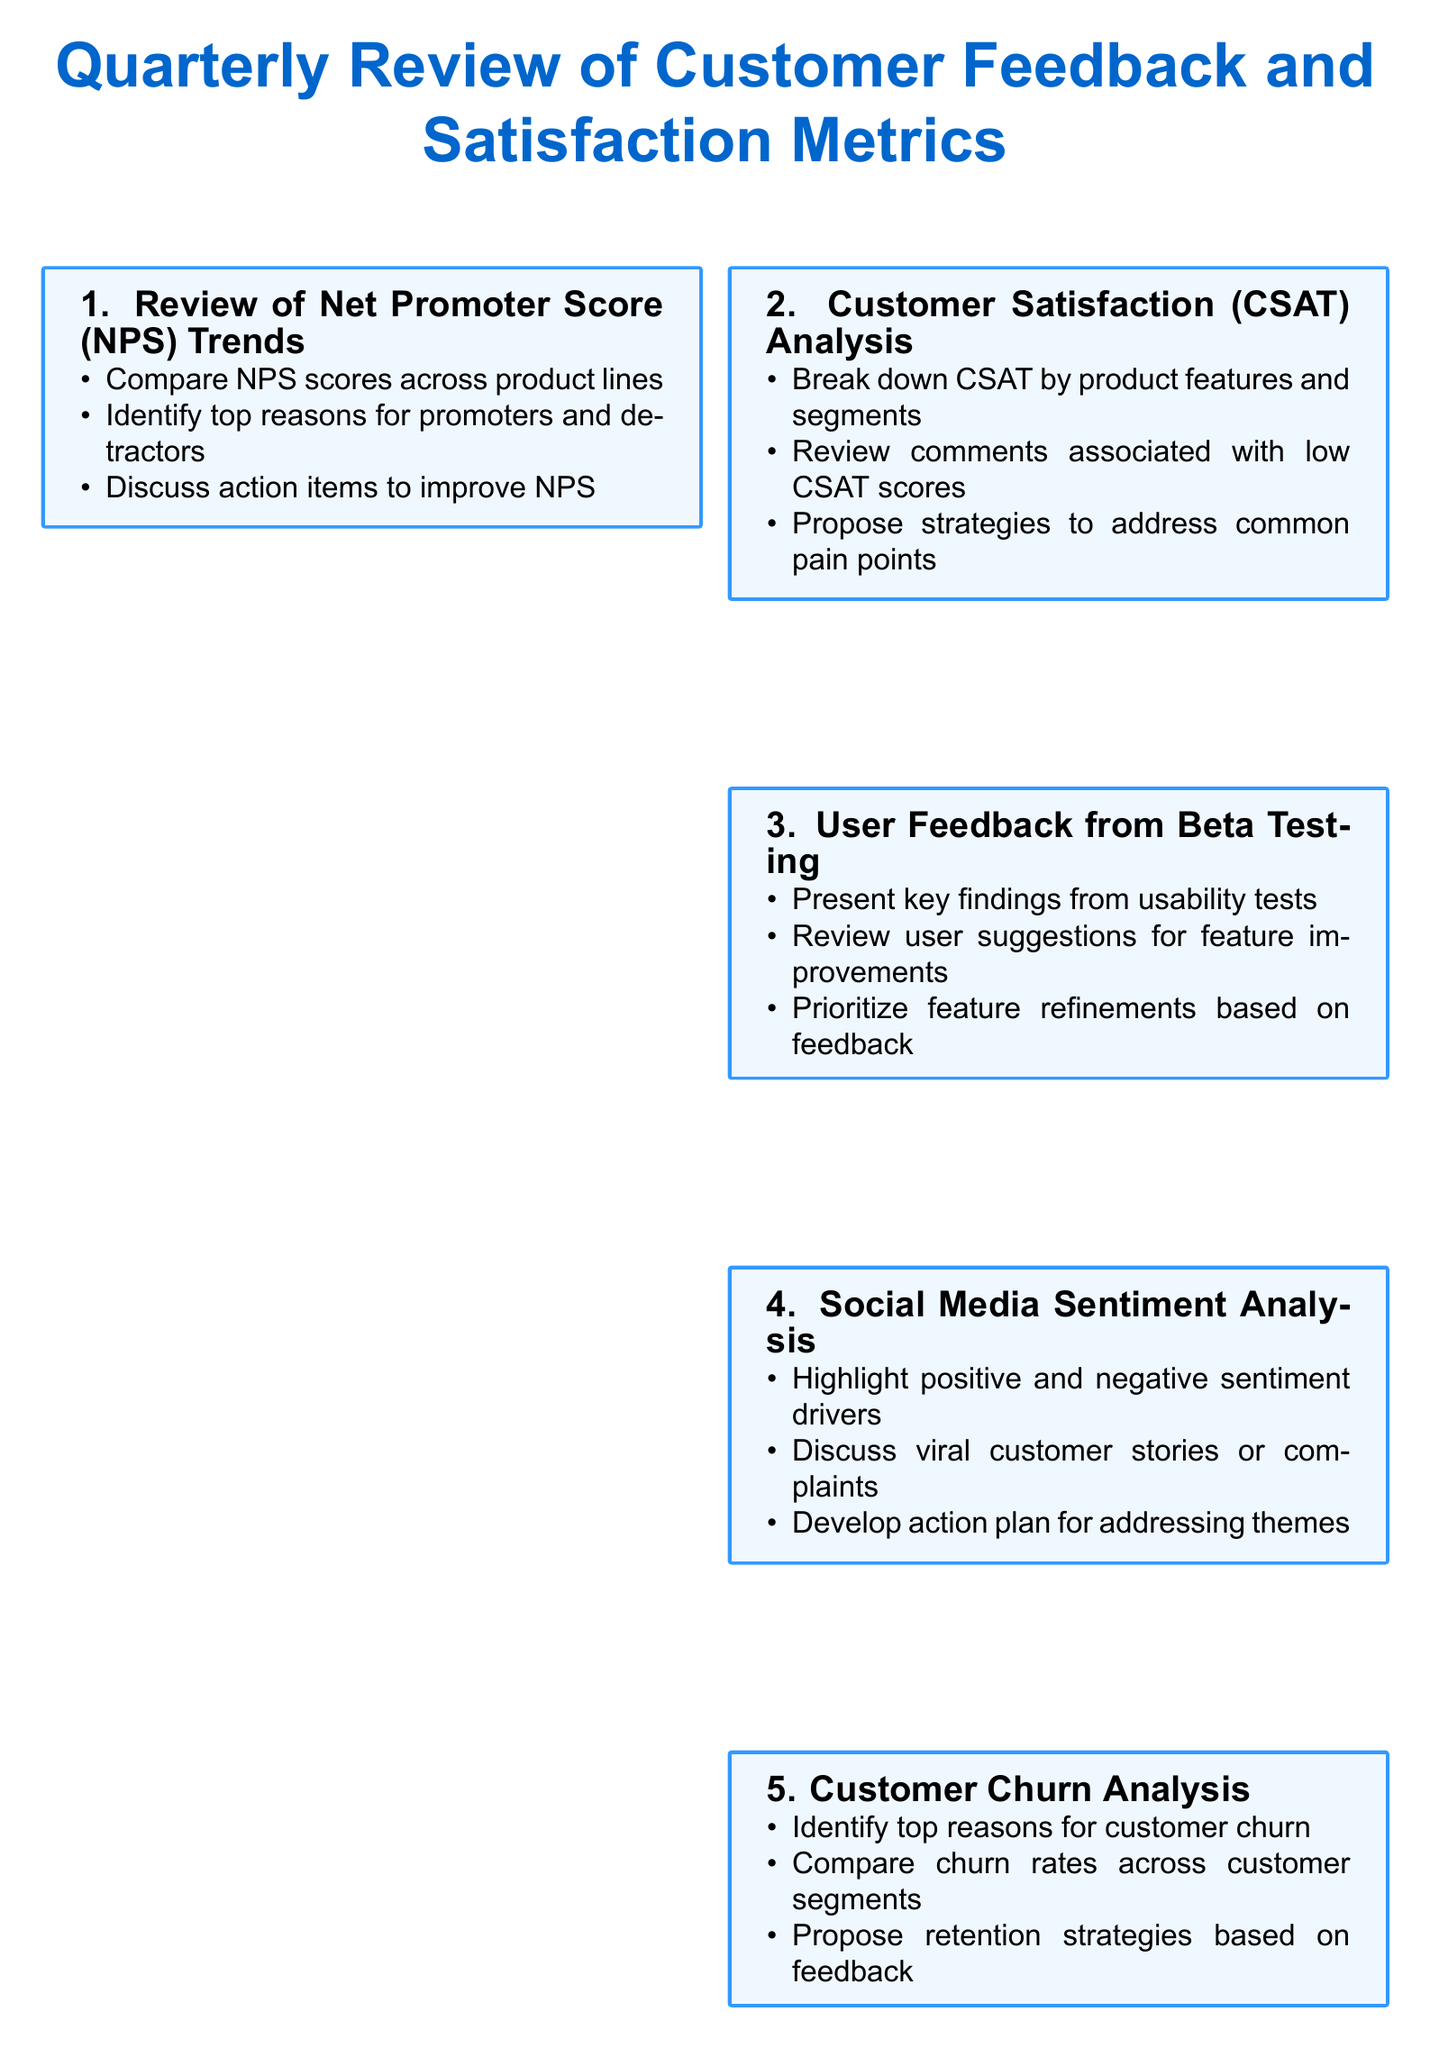What is the title of the agenda? The title of the agenda is the main heading at the top of the document, summarizing the content.
Answer: Quarterly Review of Customer Feedback and Satisfaction Metrics How many agenda items are listed? The total count of distinct sections or topics in the agenda is the required answer.
Answer: 9 What is the first item under Customer Satisfaction Analysis? The first item is the specific task listed under that agenda point which focuses on details.
Answer: Break down CSAT by product features and segments Which analytics tool is mentioned for Product Usage Metrics? The tool referred to in this section helps analyze the usage patterns of products.
Answer: Mixpanel What are the action items assigned to in the last agenda item? It refers to the distinct responsibilities that will be allocated as part of the follow-up actions.
Answer: Assign owners to key action items What common theme is discussed in Social Media Sentiment Analysis? This part of the agenda deals with identifying themes arising from customer feedback on social platforms.
Answer: Develop action plan for addressing recurring themes in social feedback What is the focus of the User Feedback from Beta Testing section? This section addresses the insights gained from user testing of new product features.
Answer: Discuss insights gathered from UserTesting.com sessions for new product features Which metric is used to measure customer loyalty? This metric is a standard measure for assessing customer satisfaction and loyalty.
Answer: Net Promoter Score (NPS) What is analyzed in the Customer Churn Analysis segment? This segment investigates specific patterns related to customer retention and dropout rates.
Answer: Quarterly churn rates and exit survey results 